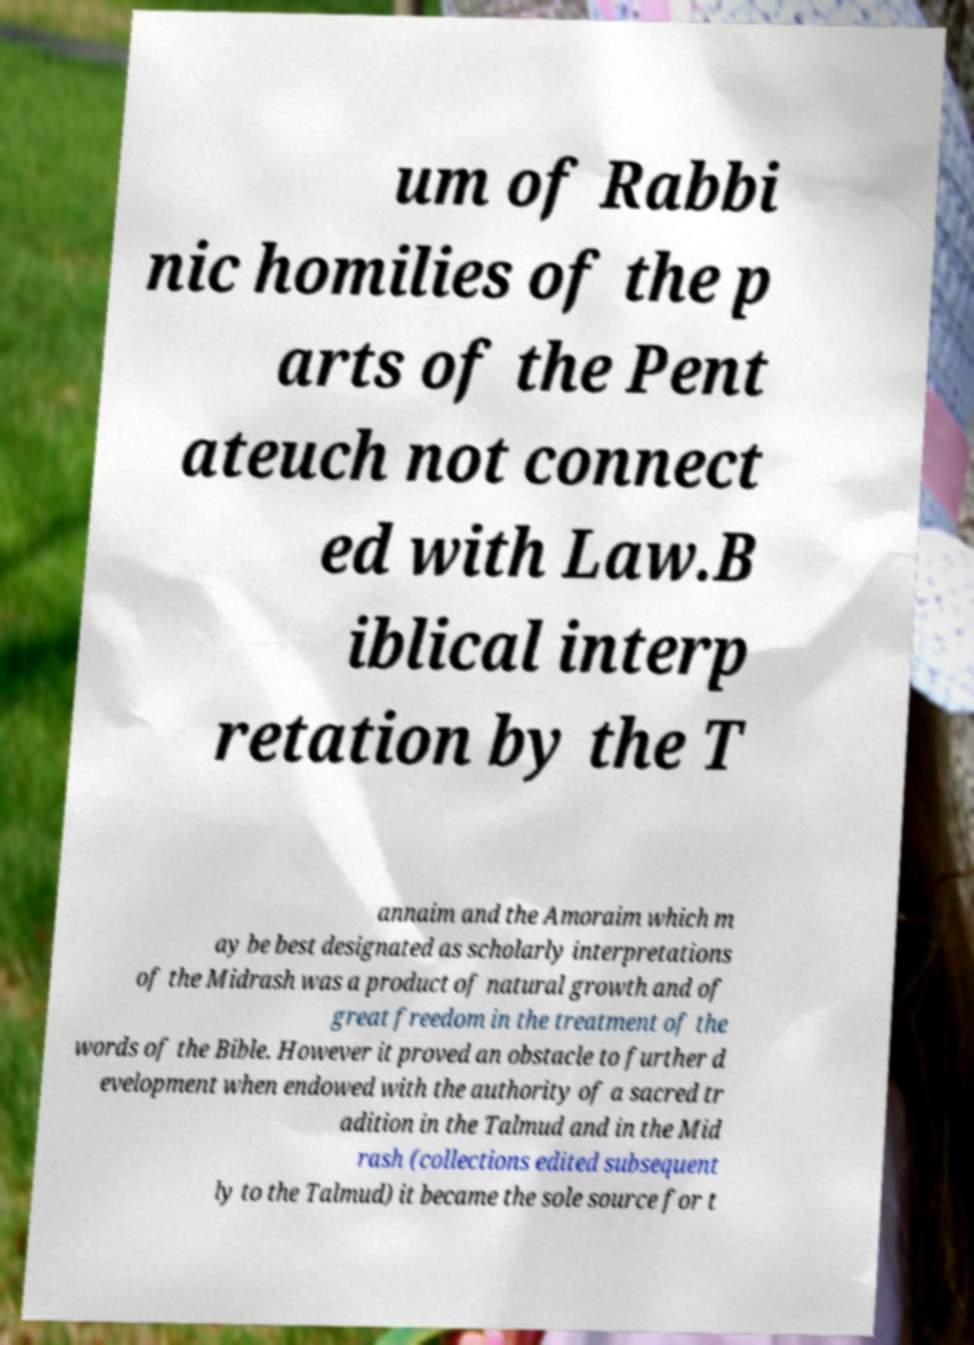Can you read and provide the text displayed in the image?This photo seems to have some interesting text. Can you extract and type it out for me? um of Rabbi nic homilies of the p arts of the Pent ateuch not connect ed with Law.B iblical interp retation by the T annaim and the Amoraim which m ay be best designated as scholarly interpretations of the Midrash was a product of natural growth and of great freedom in the treatment of the words of the Bible. However it proved an obstacle to further d evelopment when endowed with the authority of a sacred tr adition in the Talmud and in the Mid rash (collections edited subsequent ly to the Talmud) it became the sole source for t 